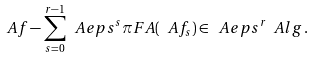Convert formula to latex. <formula><loc_0><loc_0><loc_500><loc_500>\ A f - \sum _ { s = 0 } ^ { r - 1 } \ A e p s ^ { s } \pi F A ( \ A f _ { s } ) \in \ A e p s ^ { r } \ A l g \, .</formula> 